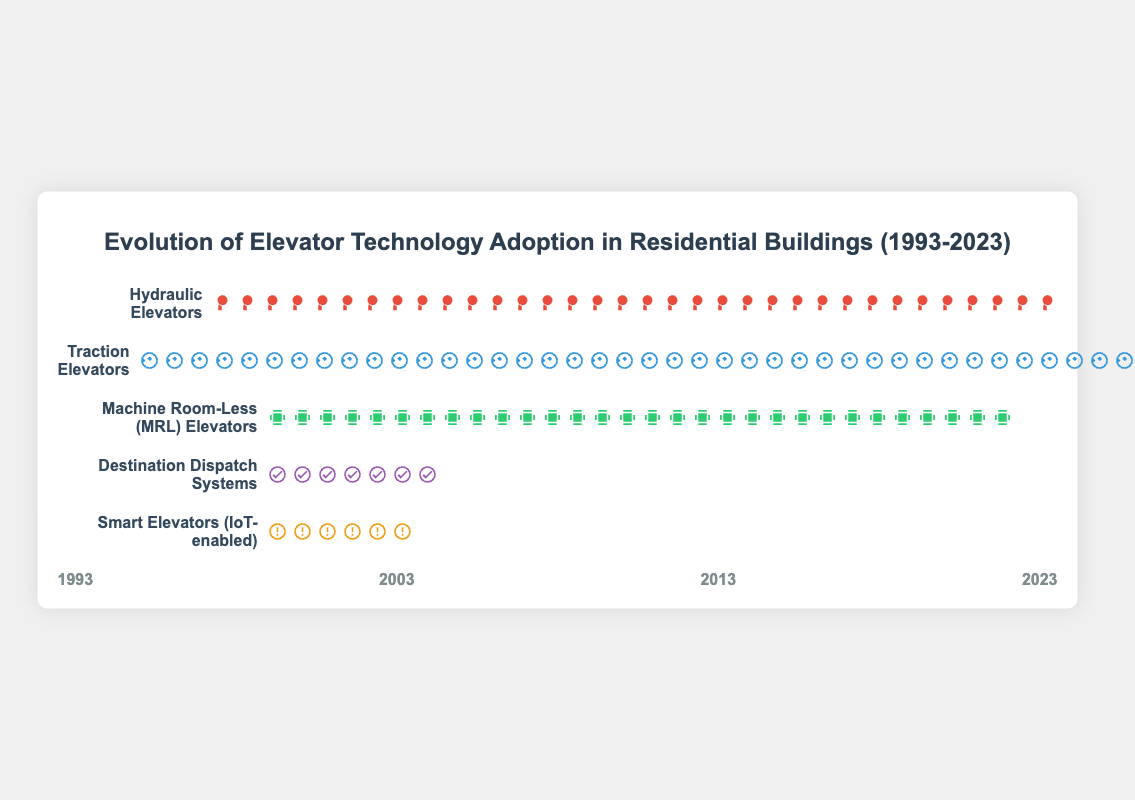What is the title of this figure? At the very top of the figure, a heading is present which indicates the title of the visualization.
Answer: Evolution of Elevator Technology Adoption in Residential Buildings (1993-2023) What technology had the highest adoption rate in 1993? By looking at the rows and icons corresponding to the year 1993, the row with the most icons indicates the highest adoption rate for that year.
Answer: Hydraulic Elevators How many icons represent Traction Elevators' adoption rate in 2023? Count the number of Traction Elevator icons in the row for 2023. Each icon represents a unit of adoption.
Answer: 10 By how much did the adoption rate of Hydraulic Elevators decline from 1993 to 2023? Find the difference in the number of icons representing Hydraulic Elevators from 1993 to 2023.
Answer: 60 Which technology saw the biggest increase in adoption rate between 2003 and 2023? Compare the increase in the number of icons for each technology from 2003 to 2023 and identify the one with the largest increase.
Answer: Smart Elevators (IoT-enabled) In 2003, which technology had a higher adoption rate: Destination Dispatch Systems or Machine Room-Less (MRL) Elevators? Compare the number of icons for Destination Dispatch Systems and Machine Room-Less (MRL) Elevators in the row for 2003.
Answer: Machine Room-Less (MRL) Elevators What is the average adoption rate of Traction Elevators over the given years? Sum the adoption rates of Traction Elevators in 1993, 2003, 2013, and 2023, then divide by 4.
Answer: 77.5 Which technology was not adopted at all in 1993? Identify the row that has no icons for the year 1993.
Answer: Machine Room-Less (MRL) Elevators, Destination Dispatch Systems, Smart Elevators (IoT-enabled) By what percentage did the adoption rate of Destination Dispatch Systems increase from 2013 to 2023? Calculate the percentage increase using the formula: ((Value in 2023 - Value in 2013) / Value in 2013) * 100.
Answer: 75% 